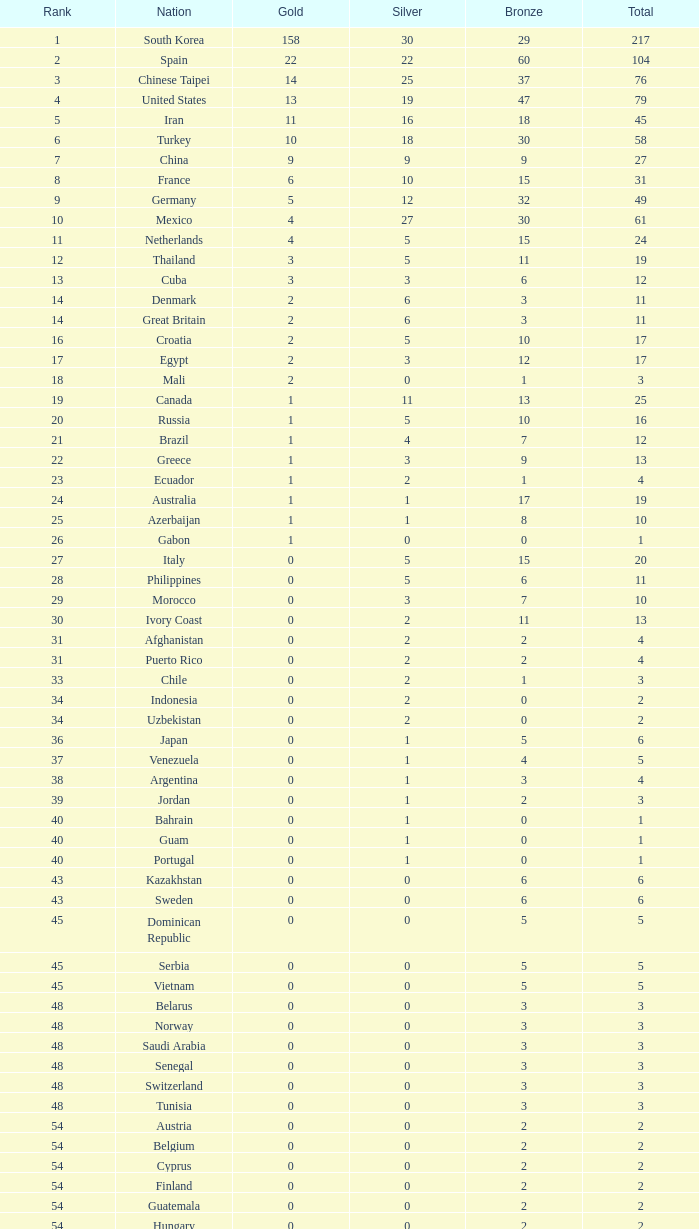What is the aggregate number of medals for the nation placed 33 with multiple bronze awards? None. Could you help me parse every detail presented in this table? {'header': ['Rank', 'Nation', 'Gold', 'Silver', 'Bronze', 'Total'], 'rows': [['1', 'South Korea', '158', '30', '29', '217'], ['2', 'Spain', '22', '22', '60', '104'], ['3', 'Chinese Taipei', '14', '25', '37', '76'], ['4', 'United States', '13', '19', '47', '79'], ['5', 'Iran', '11', '16', '18', '45'], ['6', 'Turkey', '10', '18', '30', '58'], ['7', 'China', '9', '9', '9', '27'], ['8', 'France', '6', '10', '15', '31'], ['9', 'Germany', '5', '12', '32', '49'], ['10', 'Mexico', '4', '27', '30', '61'], ['11', 'Netherlands', '4', '5', '15', '24'], ['12', 'Thailand', '3', '5', '11', '19'], ['13', 'Cuba', '3', '3', '6', '12'], ['14', 'Denmark', '2', '6', '3', '11'], ['14', 'Great Britain', '2', '6', '3', '11'], ['16', 'Croatia', '2', '5', '10', '17'], ['17', 'Egypt', '2', '3', '12', '17'], ['18', 'Mali', '2', '0', '1', '3'], ['19', 'Canada', '1', '11', '13', '25'], ['20', 'Russia', '1', '5', '10', '16'], ['21', 'Brazil', '1', '4', '7', '12'], ['22', 'Greece', '1', '3', '9', '13'], ['23', 'Ecuador', '1', '2', '1', '4'], ['24', 'Australia', '1', '1', '17', '19'], ['25', 'Azerbaijan', '1', '1', '8', '10'], ['26', 'Gabon', '1', '0', '0', '1'], ['27', 'Italy', '0', '5', '15', '20'], ['28', 'Philippines', '0', '5', '6', '11'], ['29', 'Morocco', '0', '3', '7', '10'], ['30', 'Ivory Coast', '0', '2', '11', '13'], ['31', 'Afghanistan', '0', '2', '2', '4'], ['31', 'Puerto Rico', '0', '2', '2', '4'], ['33', 'Chile', '0', '2', '1', '3'], ['34', 'Indonesia', '0', '2', '0', '2'], ['34', 'Uzbekistan', '0', '2', '0', '2'], ['36', 'Japan', '0', '1', '5', '6'], ['37', 'Venezuela', '0', '1', '4', '5'], ['38', 'Argentina', '0', '1', '3', '4'], ['39', 'Jordan', '0', '1', '2', '3'], ['40', 'Bahrain', '0', '1', '0', '1'], ['40', 'Guam', '0', '1', '0', '1'], ['40', 'Portugal', '0', '1', '0', '1'], ['43', 'Kazakhstan', '0', '0', '6', '6'], ['43', 'Sweden', '0', '0', '6', '6'], ['45', 'Dominican Republic', '0', '0', '5', '5'], ['45', 'Serbia', '0', '0', '5', '5'], ['45', 'Vietnam', '0', '0', '5', '5'], ['48', 'Belarus', '0', '0', '3', '3'], ['48', 'Norway', '0', '0', '3', '3'], ['48', 'Saudi Arabia', '0', '0', '3', '3'], ['48', 'Senegal', '0', '0', '3', '3'], ['48', 'Switzerland', '0', '0', '3', '3'], ['48', 'Tunisia', '0', '0', '3', '3'], ['54', 'Austria', '0', '0', '2', '2'], ['54', 'Belgium', '0', '0', '2', '2'], ['54', 'Cyprus', '0', '0', '2', '2'], ['54', 'Finland', '0', '0', '2', '2'], ['54', 'Guatemala', '0', '0', '2', '2'], ['54', 'Hungary', '0', '0', '2', '2'], ['54', 'Malaysia', '0', '0', '2', '2'], ['54', 'Nepal', '0', '0', '2', '2'], ['54', 'Slovenia', '0', '0', '2', '2'], ['63', 'Colombia', '0', '0', '1', '1'], ['63', 'Costa Rica', '0', '0', '1', '1'], ['63', 'Israel', '0', '0', '1', '1'], ['63', 'Nigeria', '0', '0', '1', '1'], ['63', 'Poland', '0', '0', '1', '1'], ['63', 'Uganda', '0', '0', '1', '1'], ['Total', 'Total', '280', '280', '560', '1120']]} 